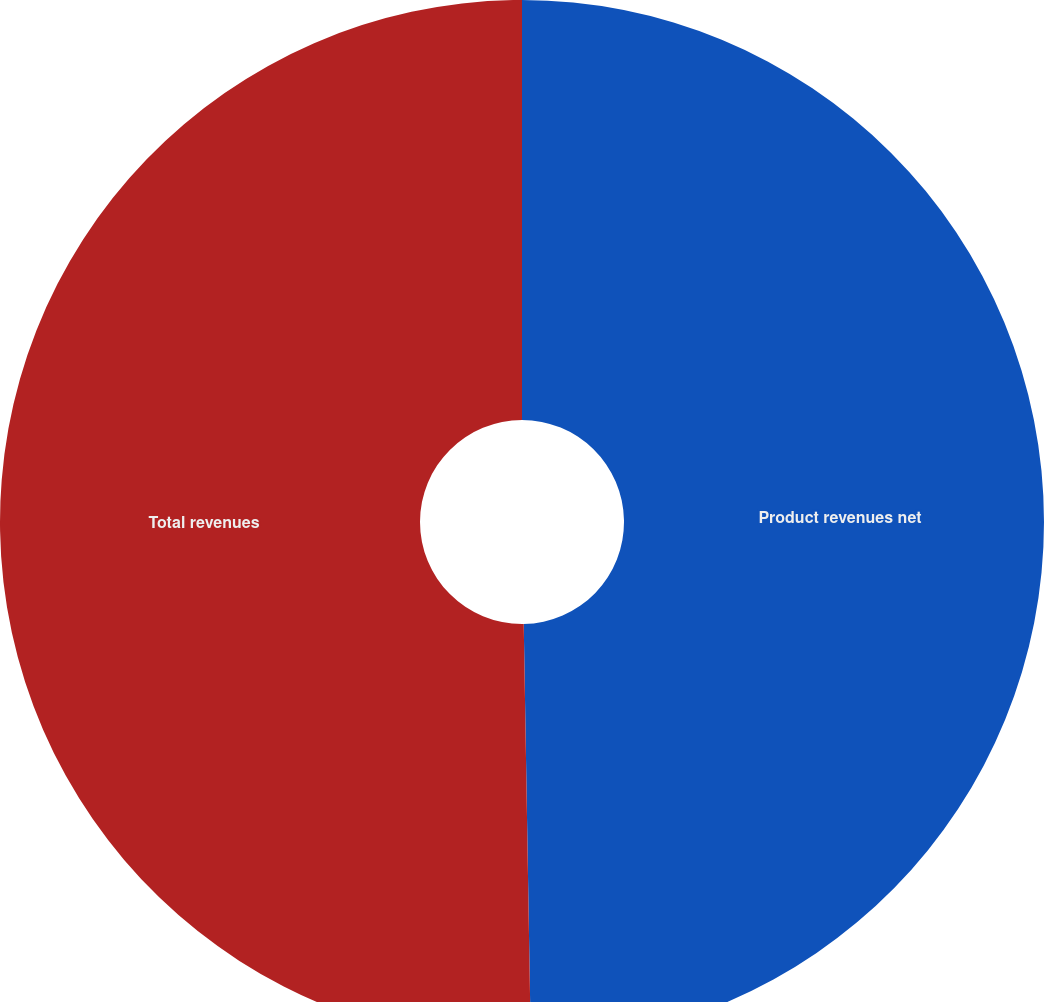Convert chart. <chart><loc_0><loc_0><loc_500><loc_500><pie_chart><fcel>Product revenues net<fcel>Total revenues<nl><fcel>49.73%<fcel>50.27%<nl></chart> 